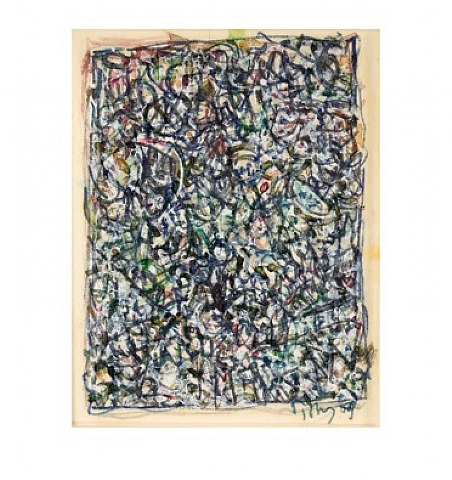What would the painting look like if it was brought to life? Imagine stepping into a dynamic, ever-changing landscape where colors flow and merge like rivers of paint, following their own paths in a mesmerizing dance. The lines and shapes in Pollock's painting would transform into three-dimensional forms, creating a labyrinthine maze that one could physically navigate through. You would hear the gentle dripping and splashing of paint, creating a rhythmic soundtrack to your exploration. The air would be filled with the scents of various pigments and mediums, adding another sensory layer to the experience. In this living painting, the environment would continually evolve, reflecting the viewer's own emotions and perceptions, making each journey through it a unique and personal adventure. How does Pollock's technique influence modern digital art? Jackson Pollock's innovative techniques have had a profound impact on modern digital art. His emphasis on spontaneity, process, and the physical act of creating art paved the way for digital artists to experiment with new methods and technologies. Techniques such as generative art, where algorithms and computer programs are used to create intricate and dynamic compositions, echo Pollock's approach to letting the medium guide the creation process.

Digital artists also often draw inspiration from Pollock's layered compositions, using software to build complex, multi-dimensional works that engage viewers similarly. His focus on texture and depth finds its counterpart in digital media through the use of layering, blending modes, and various digital brushes that mimic traditional painting techniques.

Moreover, Pollock's approach to breaking from tradition and exploring new forms of expression resonates deeply with digital artists, who continually push the boundaries of what's possible in the digital realm. By embracing unpredictability and the chance elements in their creative processes, modern digital artists continue to extend Pollock's legacy into the future. What if the painting held a secret message? What could it be? If this painting held a secret message, imagine it being a map to a hidden treasure or an ancient secret. The seemingly chaotic lines and splatters could be decoded to reveal coordinates or clues leading to an undiscovered trove of wealth or knowledge. Alternatively, the message might be more philosophical, hidden in the interplay of colors and shapes, conveying a profound truth about the human condition, the nature of creativity, or the essence of existence. Pollock's abstract language could be seen as a meditation on chaos and order, urging viewers to find their own meanings and messages within the complexity. 